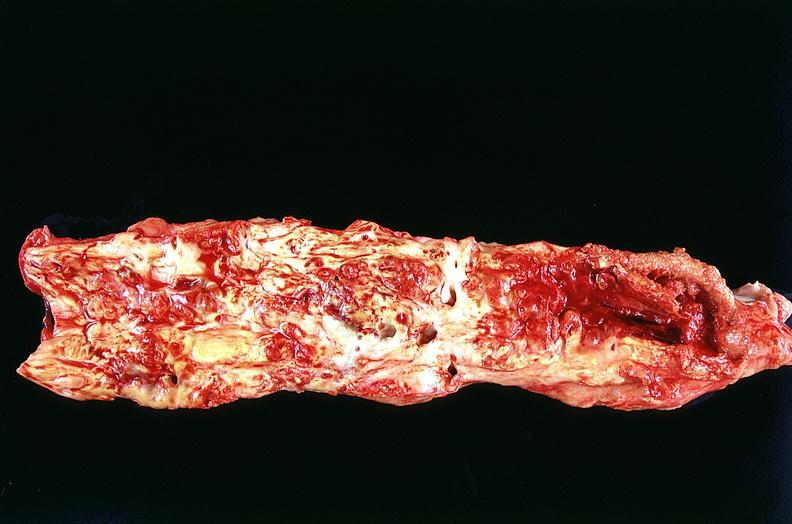what is present?
Answer the question using a single word or phrase. Vasculature 